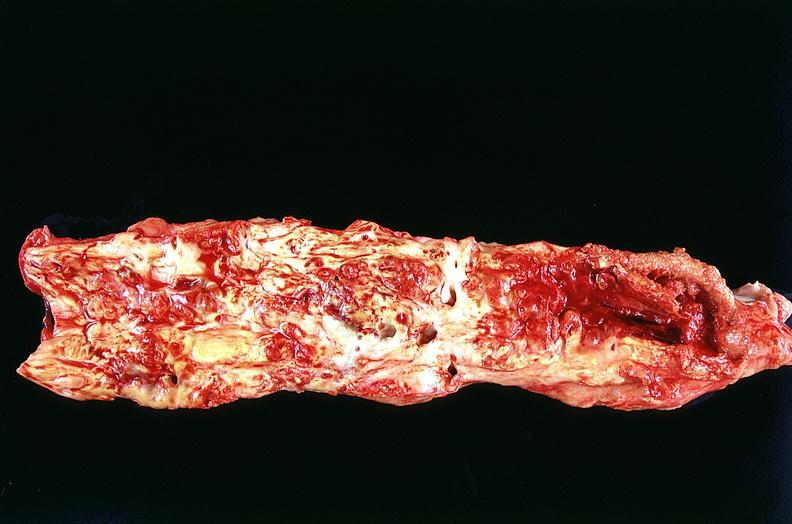what is present?
Answer the question using a single word or phrase. Vasculature 